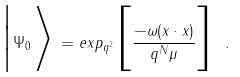<formula> <loc_0><loc_0><loc_500><loc_500>\Big | \Psi _ { 0 } \Big > \, = e x p _ { q ^ { 2 } } \Big [ { \frac { - \omega ( x \cdot x ) } { q ^ { N } \mu } } \Big ] \ .</formula> 